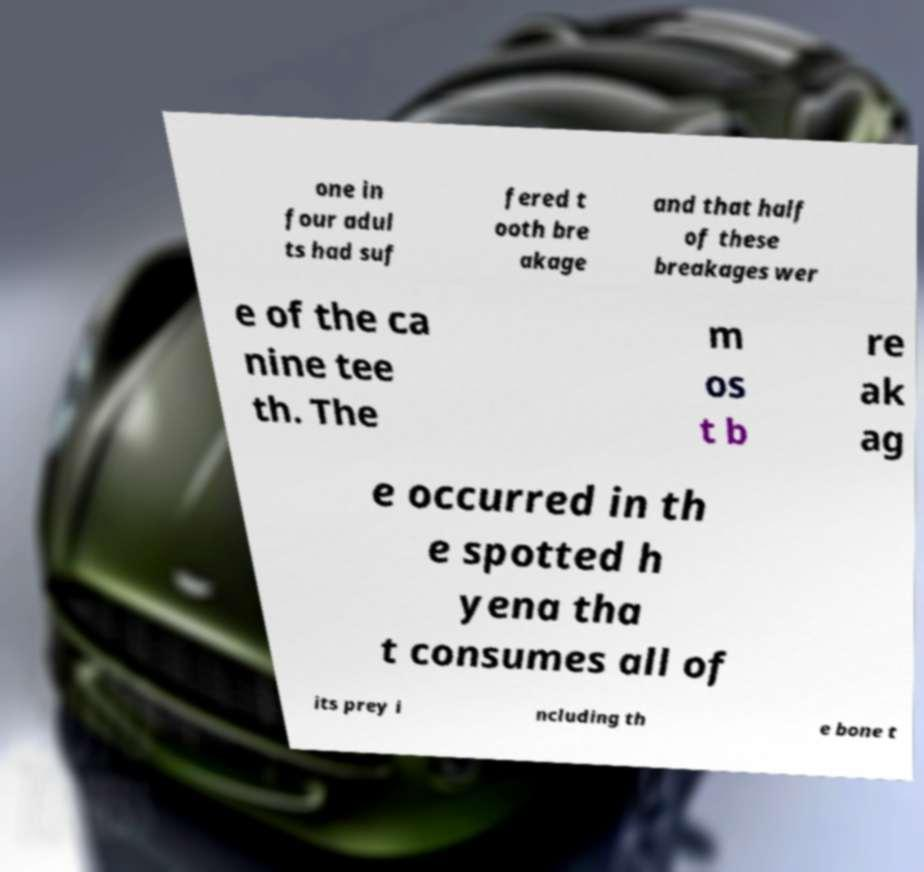Please identify and transcribe the text found in this image. one in four adul ts had suf fered t ooth bre akage and that half of these breakages wer e of the ca nine tee th. The m os t b re ak ag e occurred in th e spotted h yena tha t consumes all of its prey i ncluding th e bone t 